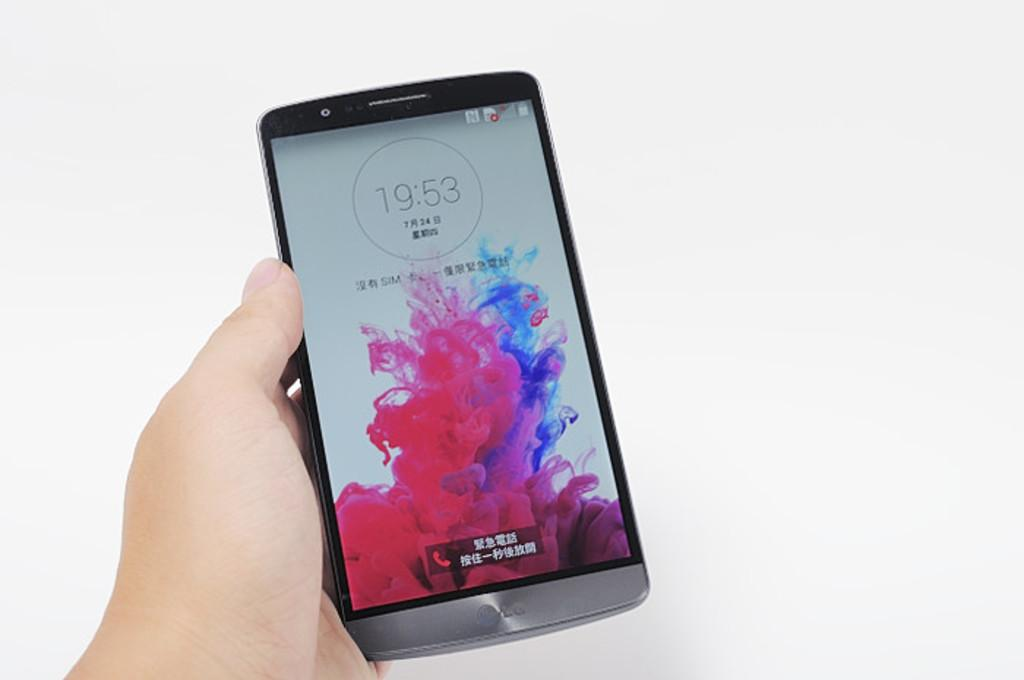<image>
Summarize the visual content of the image. a stylish cell phone with the time showing 19:53 held in a hand 